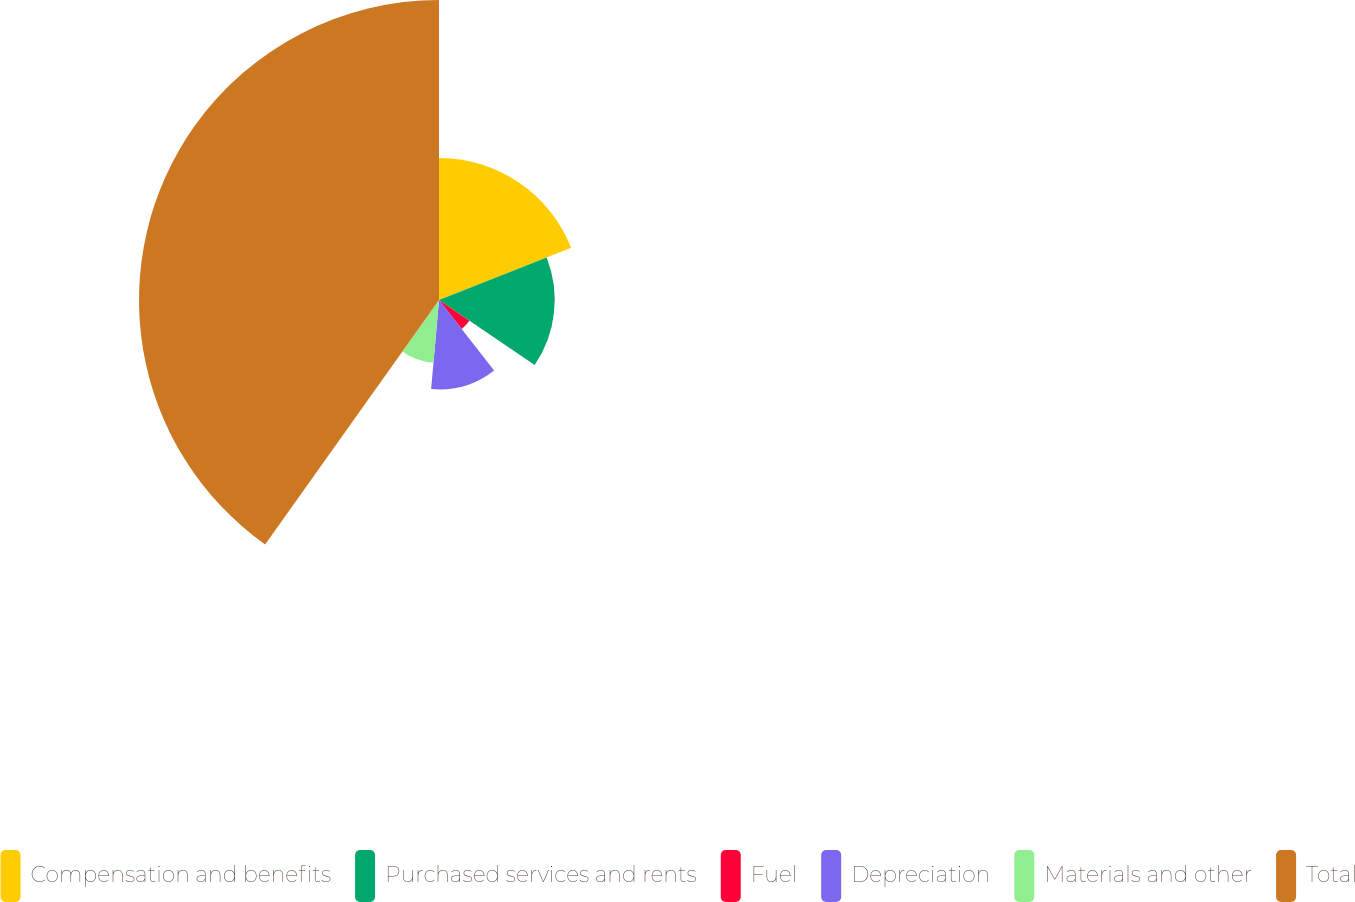<chart> <loc_0><loc_0><loc_500><loc_500><pie_chart><fcel>Compensation and benefits<fcel>Purchased services and rents<fcel>Fuel<fcel>Depreciation<fcel>Materials and other<fcel>Total<nl><fcel>19.02%<fcel>15.49%<fcel>4.92%<fcel>11.97%<fcel>8.44%<fcel>40.16%<nl></chart> 